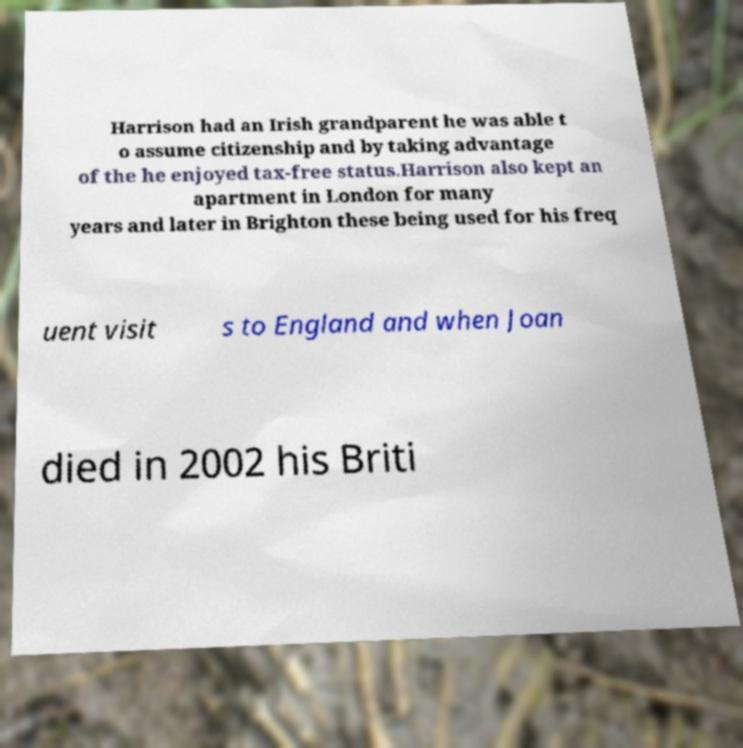Can you accurately transcribe the text from the provided image for me? Harrison had an Irish grandparent he was able t o assume citizenship and by taking advantage of the he enjoyed tax-free status.Harrison also kept an apartment in London for many years and later in Brighton these being used for his freq uent visit s to England and when Joan died in 2002 his Briti 